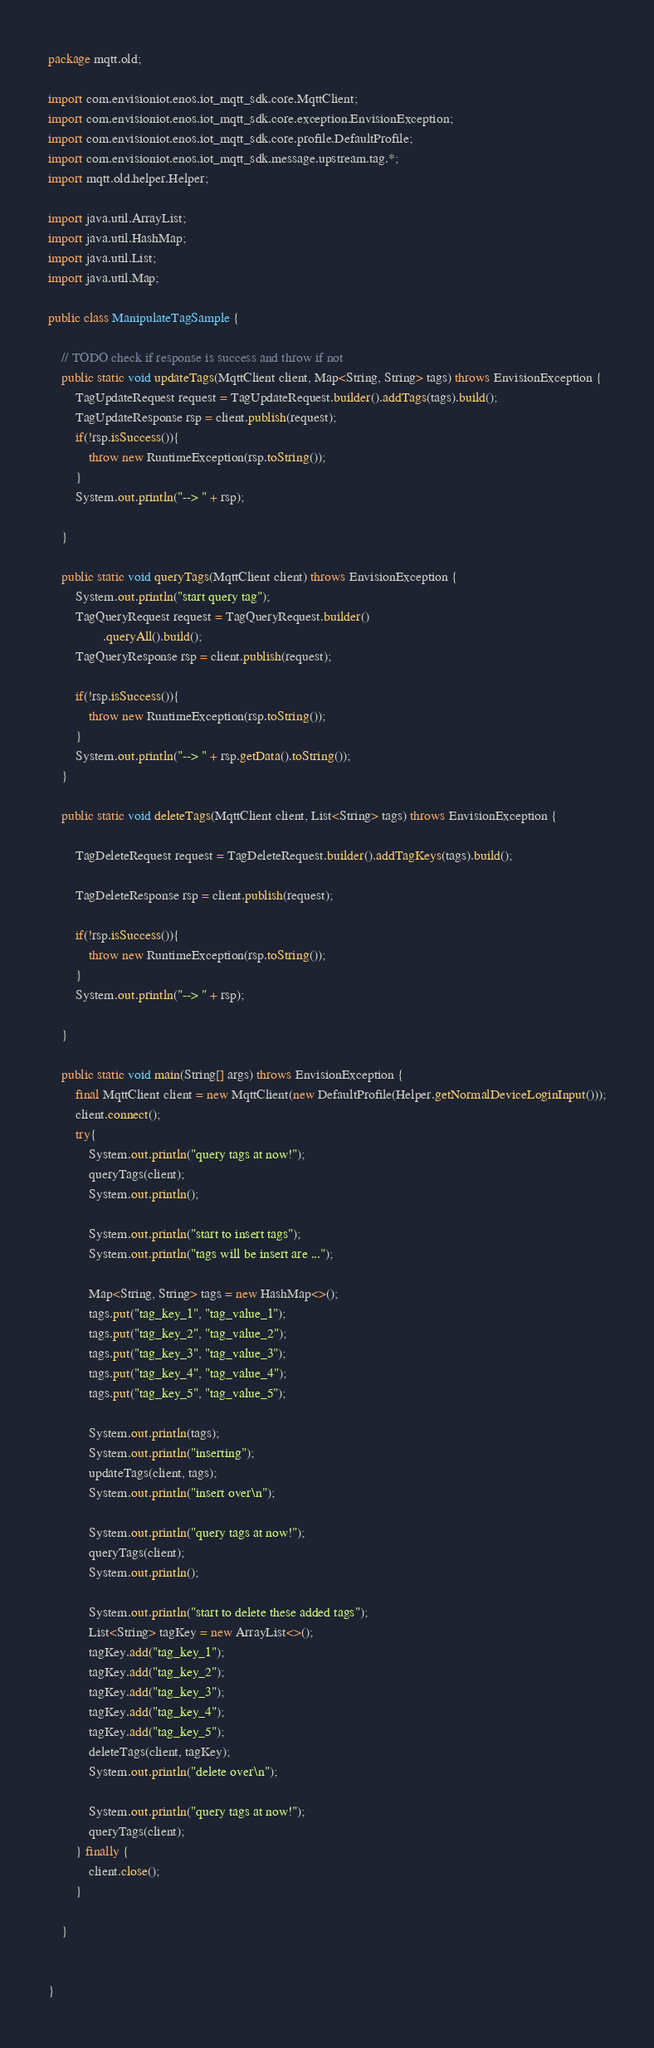Convert code to text. <code><loc_0><loc_0><loc_500><loc_500><_Java_>package mqtt.old;

import com.envisioniot.enos.iot_mqtt_sdk.core.MqttClient;
import com.envisioniot.enos.iot_mqtt_sdk.core.exception.EnvisionException;
import com.envisioniot.enos.iot_mqtt_sdk.core.profile.DefaultProfile;
import com.envisioniot.enos.iot_mqtt_sdk.message.upstream.tag.*;
import mqtt.old.helper.Helper;

import java.util.ArrayList;
import java.util.HashMap;
import java.util.List;
import java.util.Map;

public class ManipulateTagSample {

    // TODO check if response is success and throw if not
    public static void updateTags(MqttClient client, Map<String, String> tags) throws EnvisionException {
        TagUpdateRequest request = TagUpdateRequest.builder().addTags(tags).build();
        TagUpdateResponse rsp = client.publish(request);
        if(!rsp.isSuccess()){
            throw new RuntimeException(rsp.toString());
        }
        System.out.println("--> " + rsp);

    }

    public static void queryTags(MqttClient client) throws EnvisionException {
        System.out.println("start query tag");
        TagQueryRequest request = TagQueryRequest.builder()
                .queryAll().build();
        TagQueryResponse rsp = client.publish(request);

        if(!rsp.isSuccess()){
            throw new RuntimeException(rsp.toString());
        }
        System.out.println("--> " + rsp.getData().toString());
    }

    public static void deleteTags(MqttClient client, List<String> tags) throws EnvisionException {

        TagDeleteRequest request = TagDeleteRequest.builder().addTagKeys(tags).build();

        TagDeleteResponse rsp = client.publish(request);

        if(!rsp.isSuccess()){
            throw new RuntimeException(rsp.toString());
        }
        System.out.println("--> " + rsp);

    }

    public static void main(String[] args) throws EnvisionException {
        final MqttClient client = new MqttClient(new DefaultProfile(Helper.getNormalDeviceLoginInput()));
        client.connect();
        try{
            System.out.println("query tags at now!");
            queryTags(client);
            System.out.println();

            System.out.println("start to insert tags");
            System.out.println("tags will be insert are ...");

            Map<String, String> tags = new HashMap<>();
            tags.put("tag_key_1", "tag_value_1");
            tags.put("tag_key_2", "tag_value_2");
            tags.put("tag_key_3", "tag_value_3");
            tags.put("tag_key_4", "tag_value_4");
            tags.put("tag_key_5", "tag_value_5");

            System.out.println(tags);
            System.out.println("inserting");
            updateTags(client, tags);
            System.out.println("insert over\n");

            System.out.println("query tags at now!");
            queryTags(client);
            System.out.println();

            System.out.println("start to delete these added tags");
            List<String> tagKey = new ArrayList<>();
            tagKey.add("tag_key_1");
            tagKey.add("tag_key_2");
            tagKey.add("tag_key_3");
            tagKey.add("tag_key_4");
            tagKey.add("tag_key_5");
            deleteTags(client, tagKey);
            System.out.println("delete over\n");

            System.out.println("query tags at now!");
            queryTags(client);
        } finally {
            client.close();
        }

    }


}
</code> 